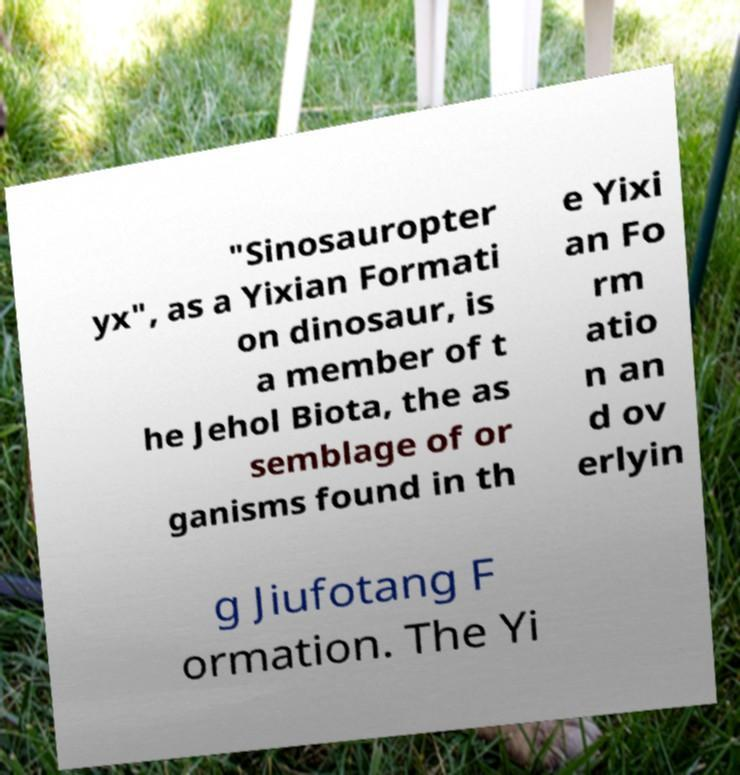What messages or text are displayed in this image? I need them in a readable, typed format. "Sinosauropter yx", as a Yixian Formati on dinosaur, is a member of t he Jehol Biota, the as semblage of or ganisms found in th e Yixi an Fo rm atio n an d ov erlyin g Jiufotang F ormation. The Yi 